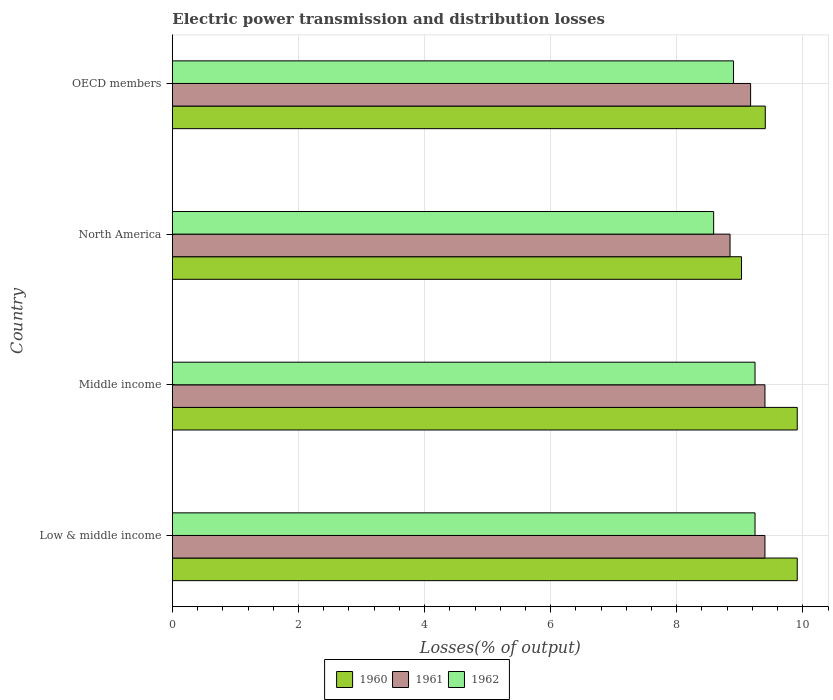How many groups of bars are there?
Make the answer very short. 4. Are the number of bars per tick equal to the number of legend labels?
Give a very brief answer. Yes. Are the number of bars on each tick of the Y-axis equal?
Make the answer very short. Yes. What is the label of the 3rd group of bars from the top?
Provide a short and direct response. Middle income. In how many cases, is the number of bars for a given country not equal to the number of legend labels?
Offer a terse response. 0. What is the electric power transmission and distribution losses in 1960 in Low & middle income?
Provide a succinct answer. 9.91. Across all countries, what is the maximum electric power transmission and distribution losses in 1960?
Ensure brevity in your answer.  9.91. Across all countries, what is the minimum electric power transmission and distribution losses in 1962?
Offer a terse response. 8.59. In which country was the electric power transmission and distribution losses in 1960 maximum?
Ensure brevity in your answer.  Low & middle income. In which country was the electric power transmission and distribution losses in 1961 minimum?
Offer a very short reply. North America. What is the total electric power transmission and distribution losses in 1962 in the graph?
Offer a very short reply. 35.97. What is the difference between the electric power transmission and distribution losses in 1960 in North America and that in OECD members?
Keep it short and to the point. -0.38. What is the difference between the electric power transmission and distribution losses in 1960 in OECD members and the electric power transmission and distribution losses in 1961 in Low & middle income?
Your response must be concise. 0.01. What is the average electric power transmission and distribution losses in 1962 per country?
Provide a short and direct response. 8.99. What is the difference between the electric power transmission and distribution losses in 1962 and electric power transmission and distribution losses in 1960 in Middle income?
Provide a short and direct response. -0.67. What is the ratio of the electric power transmission and distribution losses in 1960 in Low & middle income to that in OECD members?
Provide a short and direct response. 1.05. Is the difference between the electric power transmission and distribution losses in 1962 in Middle income and OECD members greater than the difference between the electric power transmission and distribution losses in 1960 in Middle income and OECD members?
Your response must be concise. No. What is the difference between the highest and the lowest electric power transmission and distribution losses in 1962?
Offer a very short reply. 0.66. In how many countries, is the electric power transmission and distribution losses in 1960 greater than the average electric power transmission and distribution losses in 1960 taken over all countries?
Provide a succinct answer. 2. Is the sum of the electric power transmission and distribution losses in 1960 in Middle income and OECD members greater than the maximum electric power transmission and distribution losses in 1961 across all countries?
Offer a very short reply. Yes. What does the 3rd bar from the top in OECD members represents?
Offer a very short reply. 1960. What does the 2nd bar from the bottom in North America represents?
Keep it short and to the point. 1961. Is it the case that in every country, the sum of the electric power transmission and distribution losses in 1962 and electric power transmission and distribution losses in 1960 is greater than the electric power transmission and distribution losses in 1961?
Offer a very short reply. Yes. Are all the bars in the graph horizontal?
Your answer should be compact. Yes. Does the graph contain any zero values?
Offer a terse response. No. Where does the legend appear in the graph?
Make the answer very short. Bottom center. How many legend labels are there?
Offer a very short reply. 3. What is the title of the graph?
Keep it short and to the point. Electric power transmission and distribution losses. Does "2005" appear as one of the legend labels in the graph?
Keep it short and to the point. No. What is the label or title of the X-axis?
Keep it short and to the point. Losses(% of output). What is the Losses(% of output) in 1960 in Low & middle income?
Provide a short and direct response. 9.91. What is the Losses(% of output) in 1961 in Low & middle income?
Ensure brevity in your answer.  9.4. What is the Losses(% of output) of 1962 in Low & middle income?
Your response must be concise. 9.24. What is the Losses(% of output) in 1960 in Middle income?
Ensure brevity in your answer.  9.91. What is the Losses(% of output) in 1961 in Middle income?
Your response must be concise. 9.4. What is the Losses(% of output) of 1962 in Middle income?
Keep it short and to the point. 9.24. What is the Losses(% of output) in 1960 in North America?
Make the answer very short. 9.03. What is the Losses(% of output) of 1961 in North America?
Give a very brief answer. 8.85. What is the Losses(% of output) in 1962 in North America?
Your answer should be very brief. 8.59. What is the Losses(% of output) of 1960 in OECD members?
Keep it short and to the point. 9.4. What is the Losses(% of output) of 1961 in OECD members?
Keep it short and to the point. 9.17. What is the Losses(% of output) of 1962 in OECD members?
Provide a succinct answer. 8.9. Across all countries, what is the maximum Losses(% of output) in 1960?
Make the answer very short. 9.91. Across all countries, what is the maximum Losses(% of output) in 1961?
Provide a short and direct response. 9.4. Across all countries, what is the maximum Losses(% of output) of 1962?
Keep it short and to the point. 9.24. Across all countries, what is the minimum Losses(% of output) in 1960?
Make the answer very short. 9.03. Across all countries, what is the minimum Losses(% of output) of 1961?
Offer a terse response. 8.85. Across all countries, what is the minimum Losses(% of output) of 1962?
Your response must be concise. 8.59. What is the total Losses(% of output) of 1960 in the graph?
Your response must be concise. 38.25. What is the total Losses(% of output) in 1961 in the graph?
Your response must be concise. 36.81. What is the total Losses(% of output) in 1962 in the graph?
Ensure brevity in your answer.  35.97. What is the difference between the Losses(% of output) of 1960 in Low & middle income and that in Middle income?
Provide a short and direct response. 0. What is the difference between the Losses(% of output) in 1961 in Low & middle income and that in Middle income?
Provide a succinct answer. 0. What is the difference between the Losses(% of output) of 1962 in Low & middle income and that in Middle income?
Your answer should be very brief. 0. What is the difference between the Losses(% of output) of 1960 in Low & middle income and that in North America?
Provide a succinct answer. 0.88. What is the difference between the Losses(% of output) in 1961 in Low & middle income and that in North America?
Your answer should be very brief. 0.55. What is the difference between the Losses(% of output) of 1962 in Low & middle income and that in North America?
Offer a terse response. 0.66. What is the difference between the Losses(% of output) in 1960 in Low & middle income and that in OECD members?
Keep it short and to the point. 0.51. What is the difference between the Losses(% of output) of 1961 in Low & middle income and that in OECD members?
Your answer should be very brief. 0.23. What is the difference between the Losses(% of output) in 1962 in Low & middle income and that in OECD members?
Give a very brief answer. 0.34. What is the difference between the Losses(% of output) in 1960 in Middle income and that in North America?
Your answer should be very brief. 0.88. What is the difference between the Losses(% of output) in 1961 in Middle income and that in North America?
Your answer should be compact. 0.55. What is the difference between the Losses(% of output) of 1962 in Middle income and that in North America?
Your response must be concise. 0.66. What is the difference between the Losses(% of output) in 1960 in Middle income and that in OECD members?
Provide a short and direct response. 0.51. What is the difference between the Losses(% of output) in 1961 in Middle income and that in OECD members?
Keep it short and to the point. 0.23. What is the difference between the Losses(% of output) in 1962 in Middle income and that in OECD members?
Keep it short and to the point. 0.34. What is the difference between the Losses(% of output) in 1960 in North America and that in OECD members?
Offer a terse response. -0.38. What is the difference between the Losses(% of output) in 1961 in North America and that in OECD members?
Provide a short and direct response. -0.33. What is the difference between the Losses(% of output) of 1962 in North America and that in OECD members?
Offer a terse response. -0.32. What is the difference between the Losses(% of output) in 1960 in Low & middle income and the Losses(% of output) in 1961 in Middle income?
Offer a very short reply. 0.51. What is the difference between the Losses(% of output) of 1960 in Low & middle income and the Losses(% of output) of 1962 in Middle income?
Your answer should be compact. 0.67. What is the difference between the Losses(% of output) in 1961 in Low & middle income and the Losses(% of output) in 1962 in Middle income?
Your answer should be compact. 0.16. What is the difference between the Losses(% of output) of 1960 in Low & middle income and the Losses(% of output) of 1961 in North America?
Ensure brevity in your answer.  1.07. What is the difference between the Losses(% of output) in 1960 in Low & middle income and the Losses(% of output) in 1962 in North America?
Provide a short and direct response. 1.33. What is the difference between the Losses(% of output) of 1961 in Low & middle income and the Losses(% of output) of 1962 in North America?
Your answer should be very brief. 0.81. What is the difference between the Losses(% of output) of 1960 in Low & middle income and the Losses(% of output) of 1961 in OECD members?
Offer a terse response. 0.74. What is the difference between the Losses(% of output) of 1960 in Low & middle income and the Losses(% of output) of 1962 in OECD members?
Provide a short and direct response. 1.01. What is the difference between the Losses(% of output) in 1961 in Low & middle income and the Losses(% of output) in 1962 in OECD members?
Give a very brief answer. 0.5. What is the difference between the Losses(% of output) in 1960 in Middle income and the Losses(% of output) in 1961 in North America?
Your answer should be very brief. 1.07. What is the difference between the Losses(% of output) of 1960 in Middle income and the Losses(% of output) of 1962 in North America?
Offer a very short reply. 1.33. What is the difference between the Losses(% of output) in 1961 in Middle income and the Losses(% of output) in 1962 in North America?
Your response must be concise. 0.81. What is the difference between the Losses(% of output) of 1960 in Middle income and the Losses(% of output) of 1961 in OECD members?
Your response must be concise. 0.74. What is the difference between the Losses(% of output) in 1960 in Middle income and the Losses(% of output) in 1962 in OECD members?
Provide a short and direct response. 1.01. What is the difference between the Losses(% of output) of 1961 in Middle income and the Losses(% of output) of 1962 in OECD members?
Provide a succinct answer. 0.5. What is the difference between the Losses(% of output) of 1960 in North America and the Losses(% of output) of 1961 in OECD members?
Your response must be concise. -0.14. What is the difference between the Losses(% of output) in 1960 in North America and the Losses(% of output) in 1962 in OECD members?
Ensure brevity in your answer.  0.13. What is the difference between the Losses(% of output) of 1961 in North America and the Losses(% of output) of 1962 in OECD members?
Ensure brevity in your answer.  -0.06. What is the average Losses(% of output) of 1960 per country?
Offer a very short reply. 9.56. What is the average Losses(% of output) in 1961 per country?
Make the answer very short. 9.2. What is the average Losses(% of output) in 1962 per country?
Offer a very short reply. 8.99. What is the difference between the Losses(% of output) in 1960 and Losses(% of output) in 1961 in Low & middle income?
Make the answer very short. 0.51. What is the difference between the Losses(% of output) in 1960 and Losses(% of output) in 1962 in Low & middle income?
Keep it short and to the point. 0.67. What is the difference between the Losses(% of output) in 1961 and Losses(% of output) in 1962 in Low & middle income?
Provide a short and direct response. 0.16. What is the difference between the Losses(% of output) in 1960 and Losses(% of output) in 1961 in Middle income?
Make the answer very short. 0.51. What is the difference between the Losses(% of output) of 1960 and Losses(% of output) of 1962 in Middle income?
Ensure brevity in your answer.  0.67. What is the difference between the Losses(% of output) of 1961 and Losses(% of output) of 1962 in Middle income?
Offer a very short reply. 0.16. What is the difference between the Losses(% of output) in 1960 and Losses(% of output) in 1961 in North America?
Keep it short and to the point. 0.18. What is the difference between the Losses(% of output) of 1960 and Losses(% of output) of 1962 in North America?
Provide a succinct answer. 0.44. What is the difference between the Losses(% of output) in 1961 and Losses(% of output) in 1962 in North America?
Ensure brevity in your answer.  0.26. What is the difference between the Losses(% of output) in 1960 and Losses(% of output) in 1961 in OECD members?
Keep it short and to the point. 0.23. What is the difference between the Losses(% of output) in 1960 and Losses(% of output) in 1962 in OECD members?
Give a very brief answer. 0.5. What is the difference between the Losses(% of output) in 1961 and Losses(% of output) in 1962 in OECD members?
Your answer should be very brief. 0.27. What is the ratio of the Losses(% of output) of 1961 in Low & middle income to that in Middle income?
Ensure brevity in your answer.  1. What is the ratio of the Losses(% of output) of 1960 in Low & middle income to that in North America?
Provide a short and direct response. 1.1. What is the ratio of the Losses(% of output) in 1961 in Low & middle income to that in North America?
Provide a succinct answer. 1.06. What is the ratio of the Losses(% of output) in 1962 in Low & middle income to that in North America?
Your answer should be very brief. 1.08. What is the ratio of the Losses(% of output) in 1960 in Low & middle income to that in OECD members?
Your response must be concise. 1.05. What is the ratio of the Losses(% of output) of 1961 in Low & middle income to that in OECD members?
Ensure brevity in your answer.  1.02. What is the ratio of the Losses(% of output) in 1962 in Low & middle income to that in OECD members?
Ensure brevity in your answer.  1.04. What is the ratio of the Losses(% of output) in 1960 in Middle income to that in North America?
Your response must be concise. 1.1. What is the ratio of the Losses(% of output) of 1961 in Middle income to that in North America?
Your answer should be compact. 1.06. What is the ratio of the Losses(% of output) of 1962 in Middle income to that in North America?
Your answer should be compact. 1.08. What is the ratio of the Losses(% of output) in 1960 in Middle income to that in OECD members?
Your answer should be compact. 1.05. What is the ratio of the Losses(% of output) of 1961 in Middle income to that in OECD members?
Your answer should be compact. 1.02. What is the ratio of the Losses(% of output) in 1962 in Middle income to that in OECD members?
Offer a very short reply. 1.04. What is the ratio of the Losses(% of output) of 1960 in North America to that in OECD members?
Provide a succinct answer. 0.96. What is the ratio of the Losses(% of output) in 1961 in North America to that in OECD members?
Offer a very short reply. 0.96. What is the ratio of the Losses(% of output) in 1962 in North America to that in OECD members?
Ensure brevity in your answer.  0.96. What is the difference between the highest and the second highest Losses(% of output) of 1960?
Provide a succinct answer. 0. What is the difference between the highest and the second highest Losses(% of output) of 1961?
Your answer should be compact. 0. What is the difference between the highest and the second highest Losses(% of output) of 1962?
Offer a very short reply. 0. What is the difference between the highest and the lowest Losses(% of output) in 1960?
Provide a short and direct response. 0.88. What is the difference between the highest and the lowest Losses(% of output) of 1961?
Your answer should be very brief. 0.55. What is the difference between the highest and the lowest Losses(% of output) in 1962?
Ensure brevity in your answer.  0.66. 